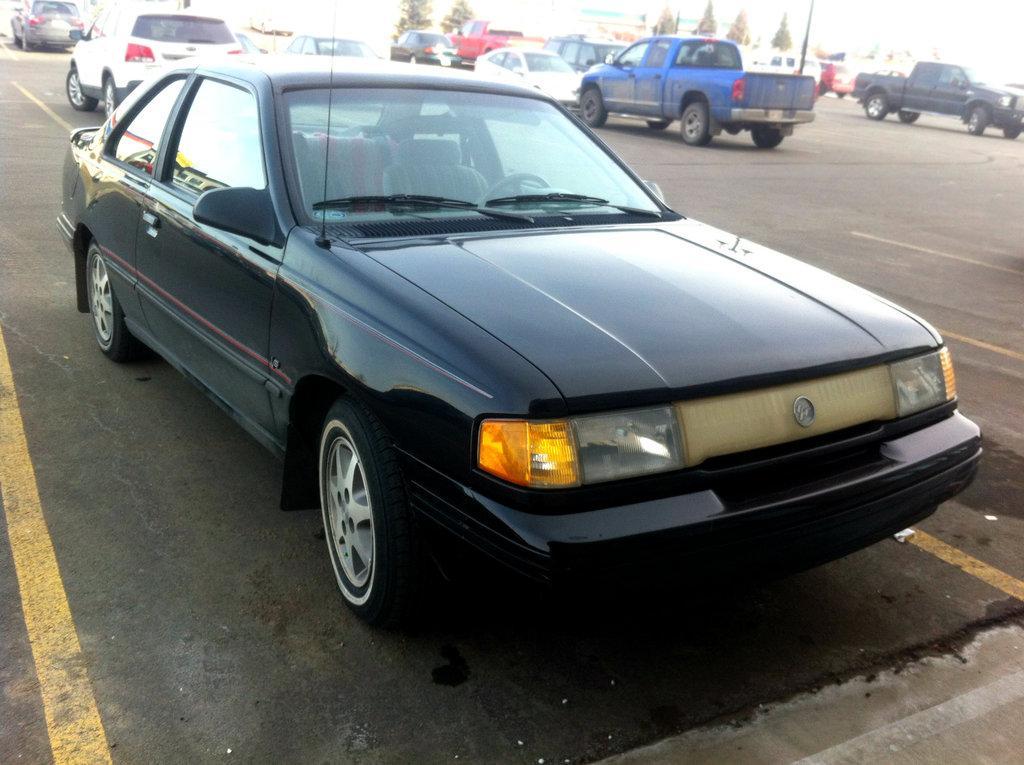Could you give a brief overview of what you see in this image? In this image we can see cars on the road. In the background of the image there are trees. 